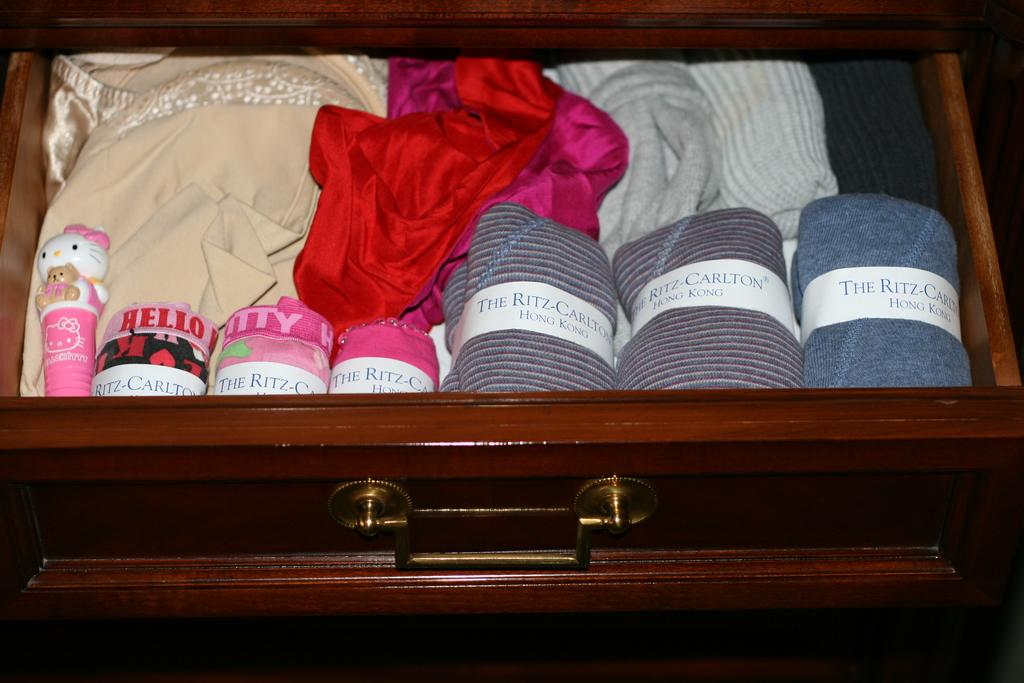What hotel are these from?
Your response must be concise. The ritz-carlton hong kong. What does the left most clothes say?
Your response must be concise. Hello. 